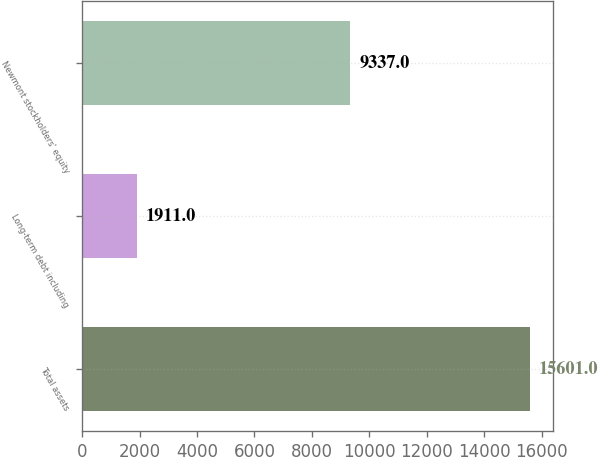<chart> <loc_0><loc_0><loc_500><loc_500><bar_chart><fcel>Total assets<fcel>Long-term debt including<fcel>Newmont stockholders' equity<nl><fcel>15601<fcel>1911<fcel>9337<nl></chart> 